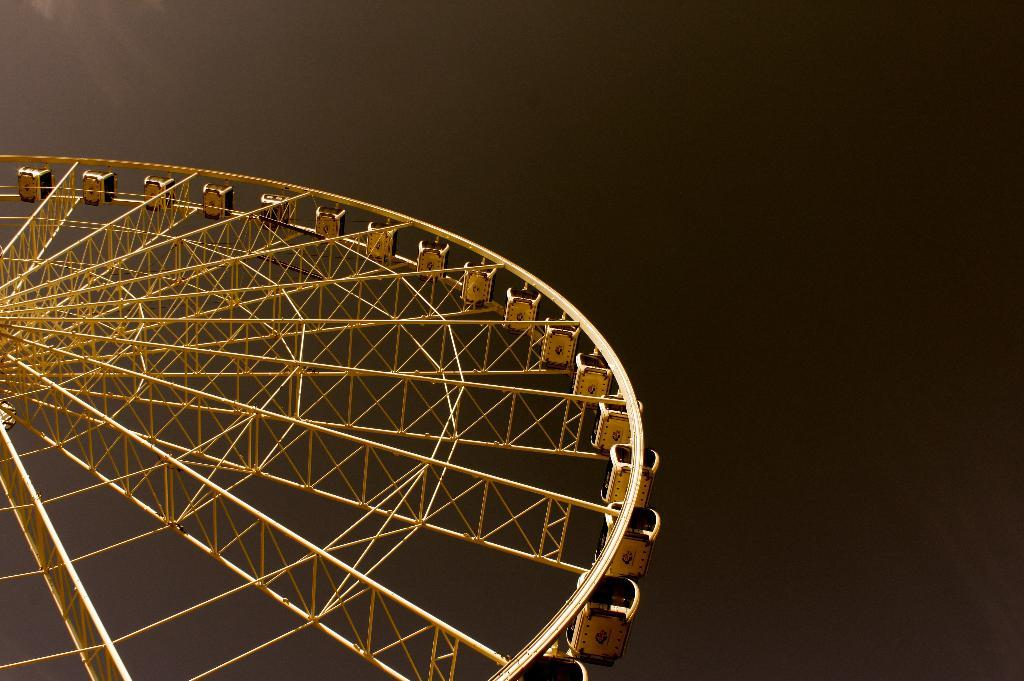What is the main subject of the image? The main subject of the image is a giant wheel. How many potatoes are attached to the giant wheel in the image? There are no potatoes present in the image; it features a giant wheel. What type of thread is used to hold the head in place on the giant wheel? There is no head or thread present in the image; it only features a giant wheel. 